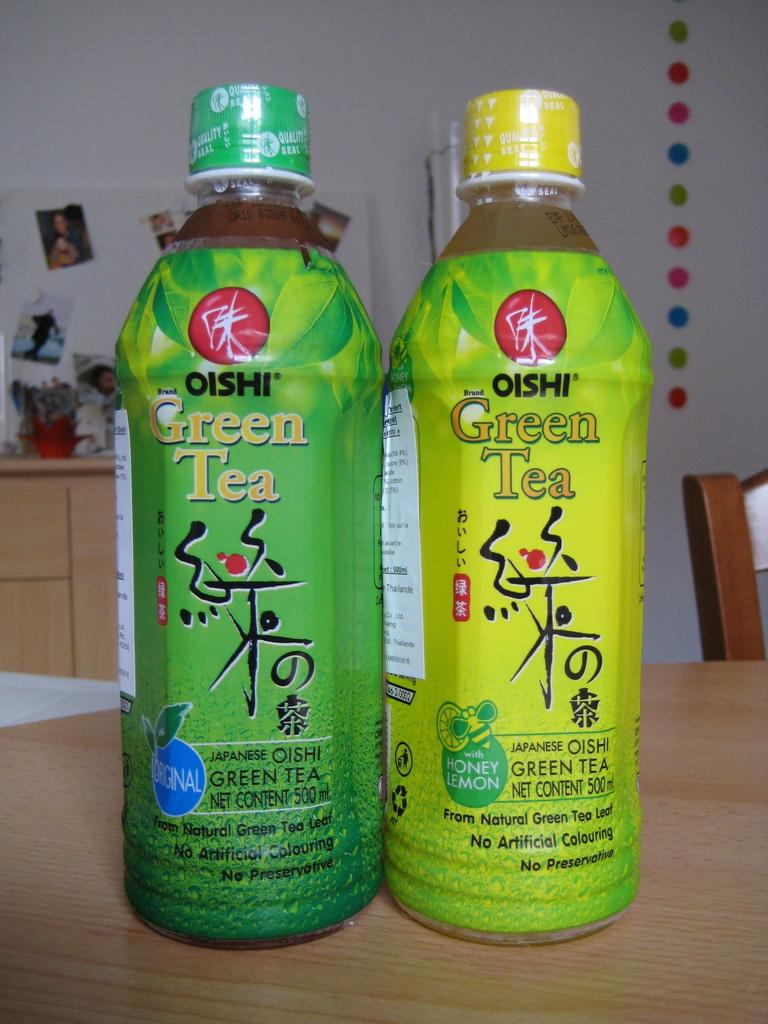<image>
Provide a brief description of the given image. the word green is on the bottle that is green 